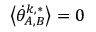<formula> <loc_0><loc_0><loc_500><loc_500>\left \langle \dot { \theta } _ { A , B } ^ { k , * } \right \rangle = 0</formula> 